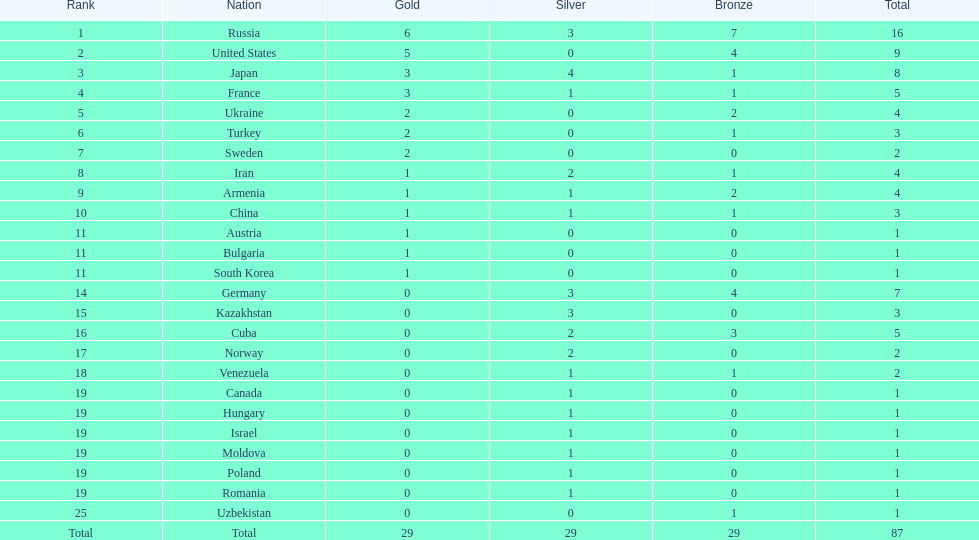What was iran's position? 8. What was germany's position? 14. Which one of them made it to the top 10 positions? Germany. 